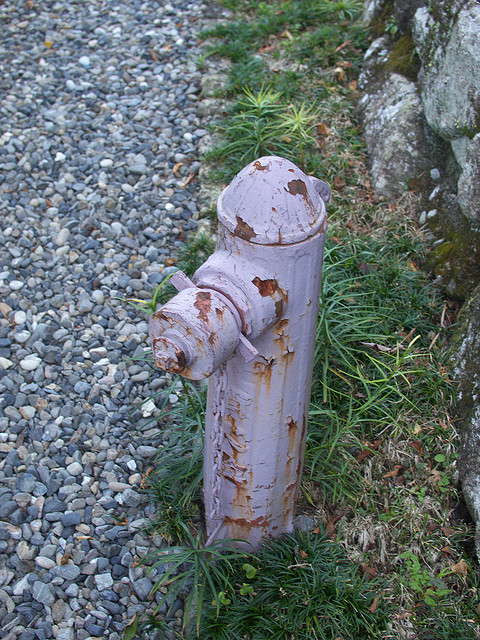Can you describe its condition? Certainly. The fireplug appears to be quite old and weathered. It has a purple-pinkish hue, but the paint is chipping off in several areas, exposing the underlying metal. This wear suggests it has been exposed to the elements for a considerable period. 